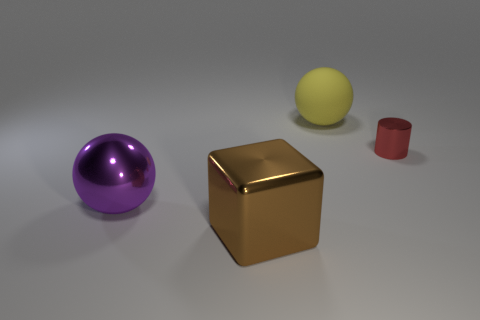Add 4 cylinders. How many objects exist? 8 Subtract all cylinders. How many objects are left? 3 Subtract 0 brown cylinders. How many objects are left? 4 Subtract all gray cubes. Subtract all big metallic objects. How many objects are left? 2 Add 1 brown shiny objects. How many brown shiny objects are left? 2 Add 2 blue rubber cylinders. How many blue rubber cylinders exist? 2 